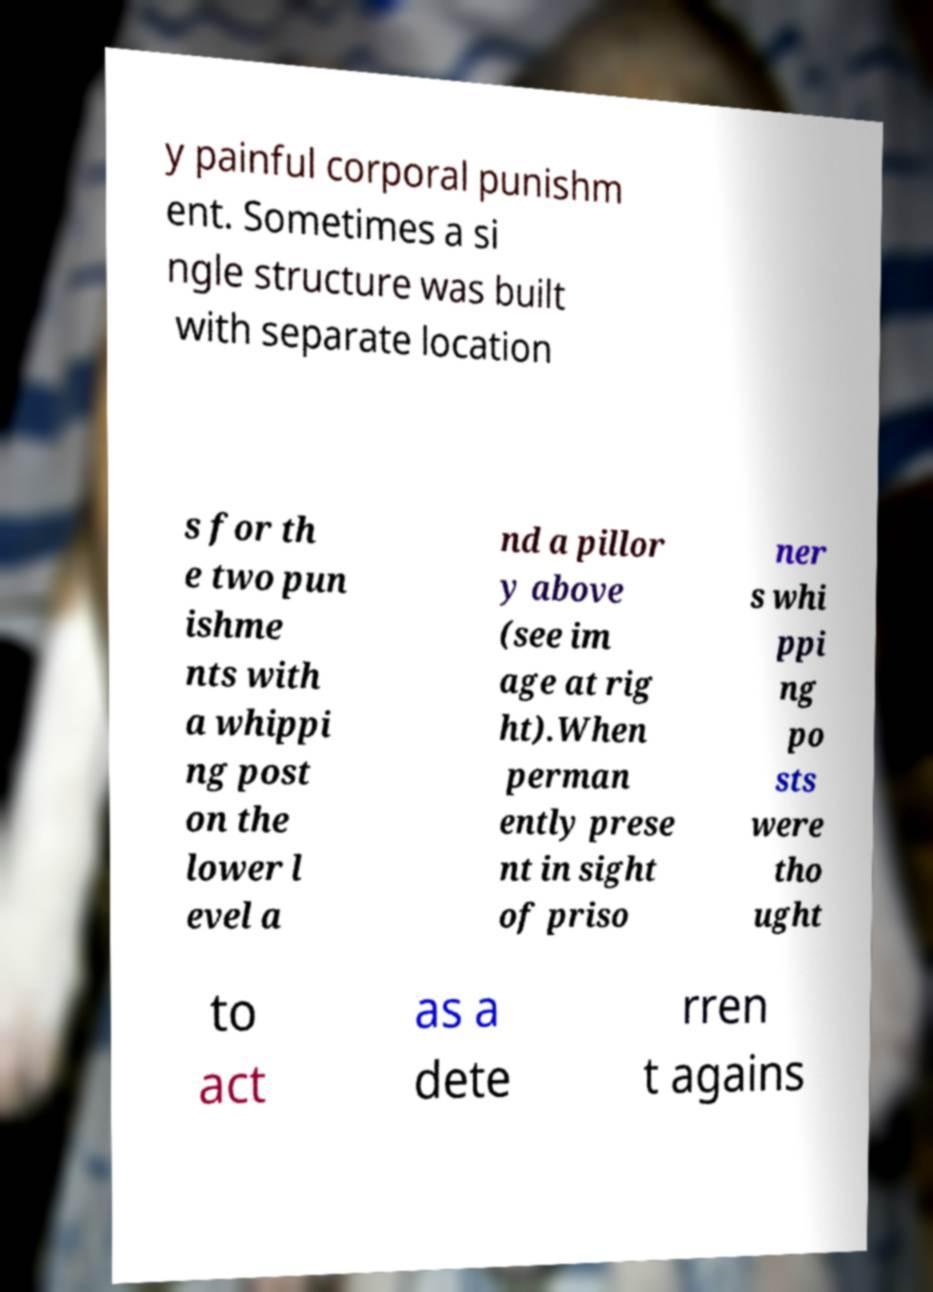There's text embedded in this image that I need extracted. Can you transcribe it verbatim? y painful corporal punishm ent. Sometimes a si ngle structure was built with separate location s for th e two pun ishme nts with a whippi ng post on the lower l evel a nd a pillor y above (see im age at rig ht).When perman ently prese nt in sight of priso ner s whi ppi ng po sts were tho ught to act as a dete rren t agains 